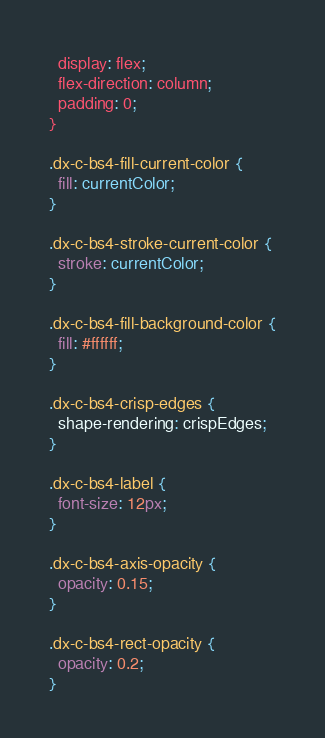Convert code to text. <code><loc_0><loc_0><loc_500><loc_500><_CSS_>  display: flex;
  flex-direction: column;
  padding: 0;
}

.dx-c-bs4-fill-current-color {
  fill: currentColor;
}

.dx-c-bs4-stroke-current-color {
  stroke: currentColor;
}

.dx-c-bs4-fill-background-color {
  fill: #ffffff;
}

.dx-c-bs4-crisp-edges {
  shape-rendering: crispEdges;
}

.dx-c-bs4-label {
  font-size: 12px;
}

.dx-c-bs4-axis-opacity {
  opacity: 0.15;
}

.dx-c-bs4-rect-opacity {
  opacity: 0.2;
}</code> 